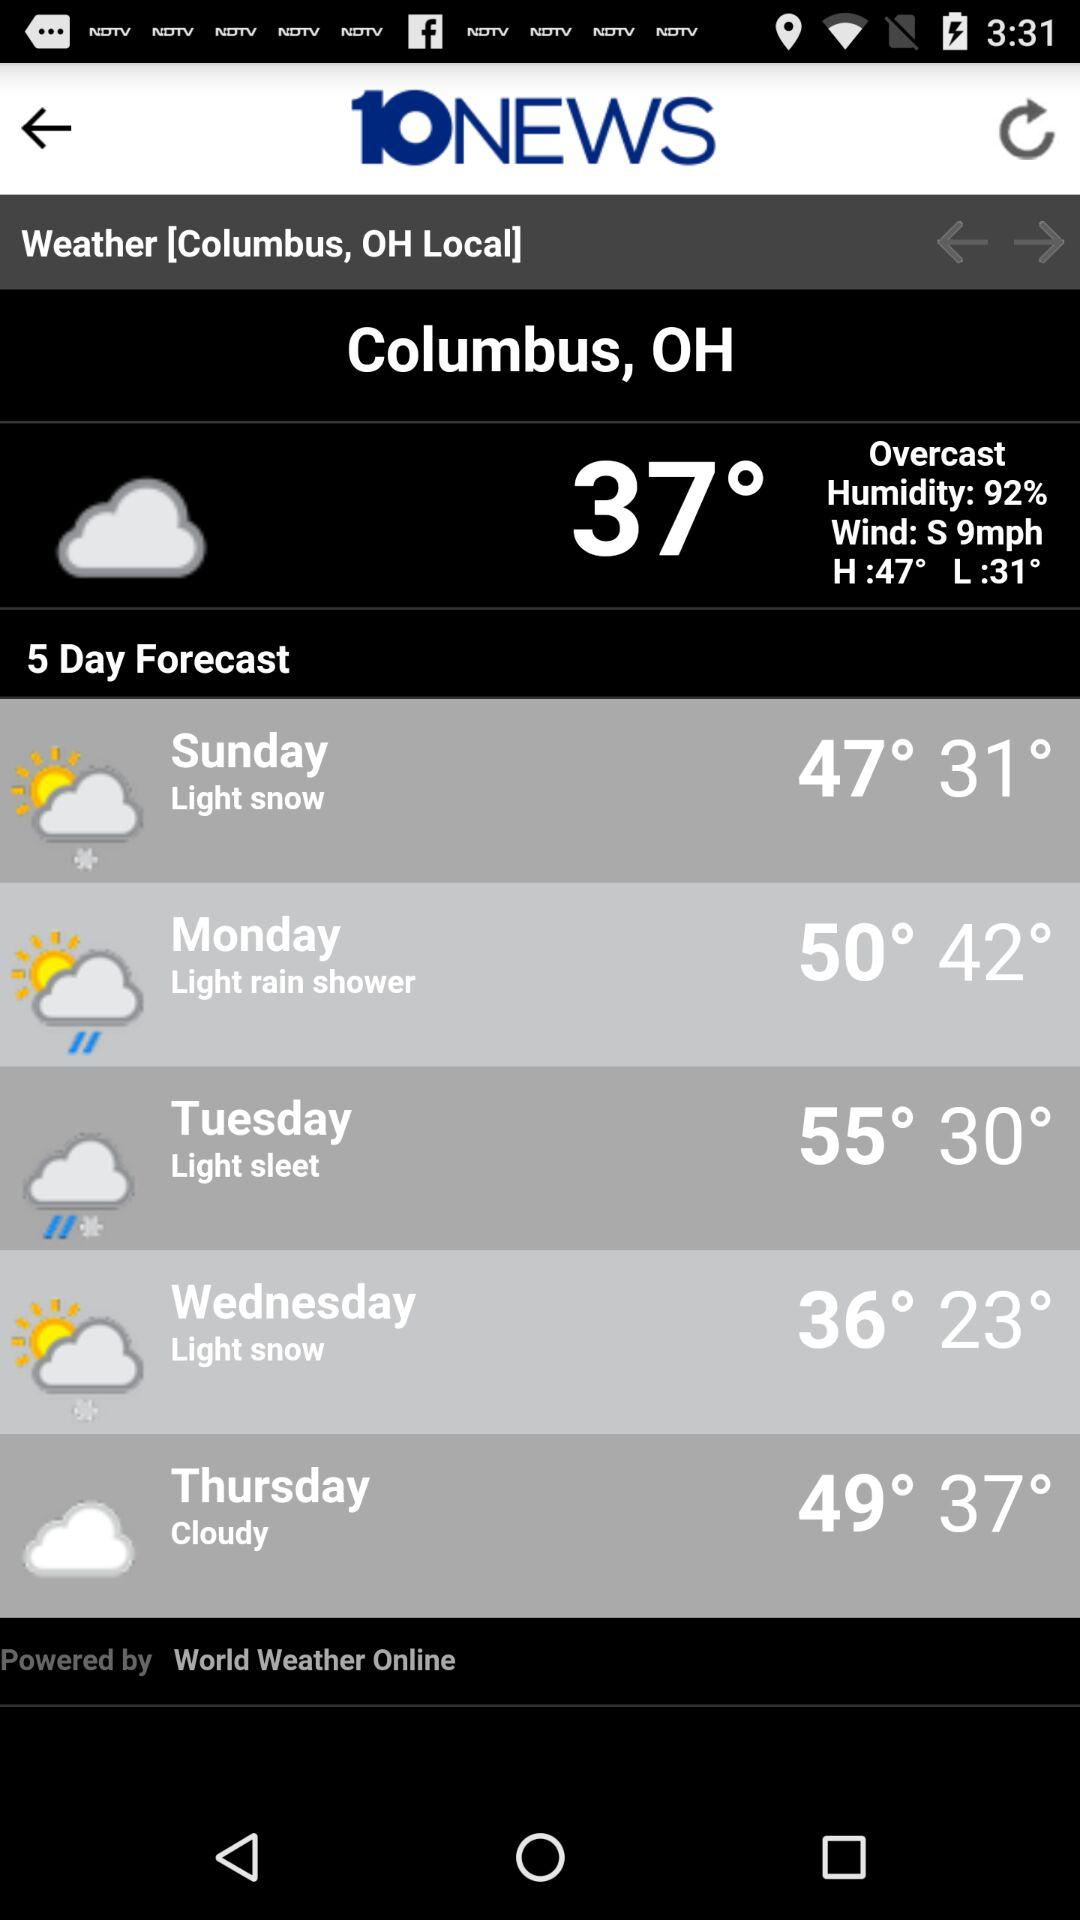Will it be cloudy again on Friday? Yes, it will be cloudy on Friday. The image displays the weather forecast for Columbus, OH showing that Thursday will have cloudy weather, which suggests a continuation into Friday. 